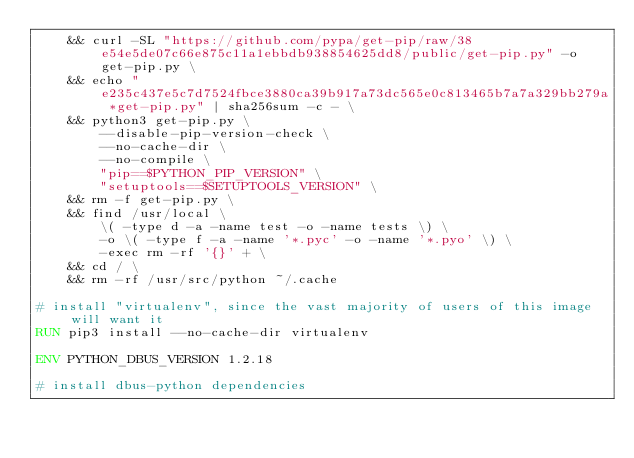<code> <loc_0><loc_0><loc_500><loc_500><_Dockerfile_>	&& curl -SL "https://github.com/pypa/get-pip/raw/38e54e5de07c66e875c11a1ebbdb938854625dd8/public/get-pip.py" -o get-pip.py \
    && echo "e235c437e5c7d7524fbce3880ca39b917a73dc565e0c813465b7a7a329bb279a *get-pip.py" | sha256sum -c - \
    && python3 get-pip.py \
        --disable-pip-version-check \
        --no-cache-dir \
        --no-compile \
        "pip==$PYTHON_PIP_VERSION" \
        "setuptools==$SETUPTOOLS_VERSION" \
	&& rm -f get-pip.py \
	&& find /usr/local \
		\( -type d -a -name test -o -name tests \) \
		-o \( -type f -a -name '*.pyc' -o -name '*.pyo' \) \
		-exec rm -rf '{}' + \
	&& cd / \
	&& rm -rf /usr/src/python ~/.cache

# install "virtualenv", since the vast majority of users of this image will want it
RUN pip3 install --no-cache-dir virtualenv

ENV PYTHON_DBUS_VERSION 1.2.18

# install dbus-python dependencies </code> 